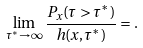<formula> <loc_0><loc_0><loc_500><loc_500>\lim _ { \tau ^ { * } \to \infty } \frac { P _ { x } ( \tau > \tau ^ { * } ) } { h ( x , \tau ^ { * } ) } = .</formula> 